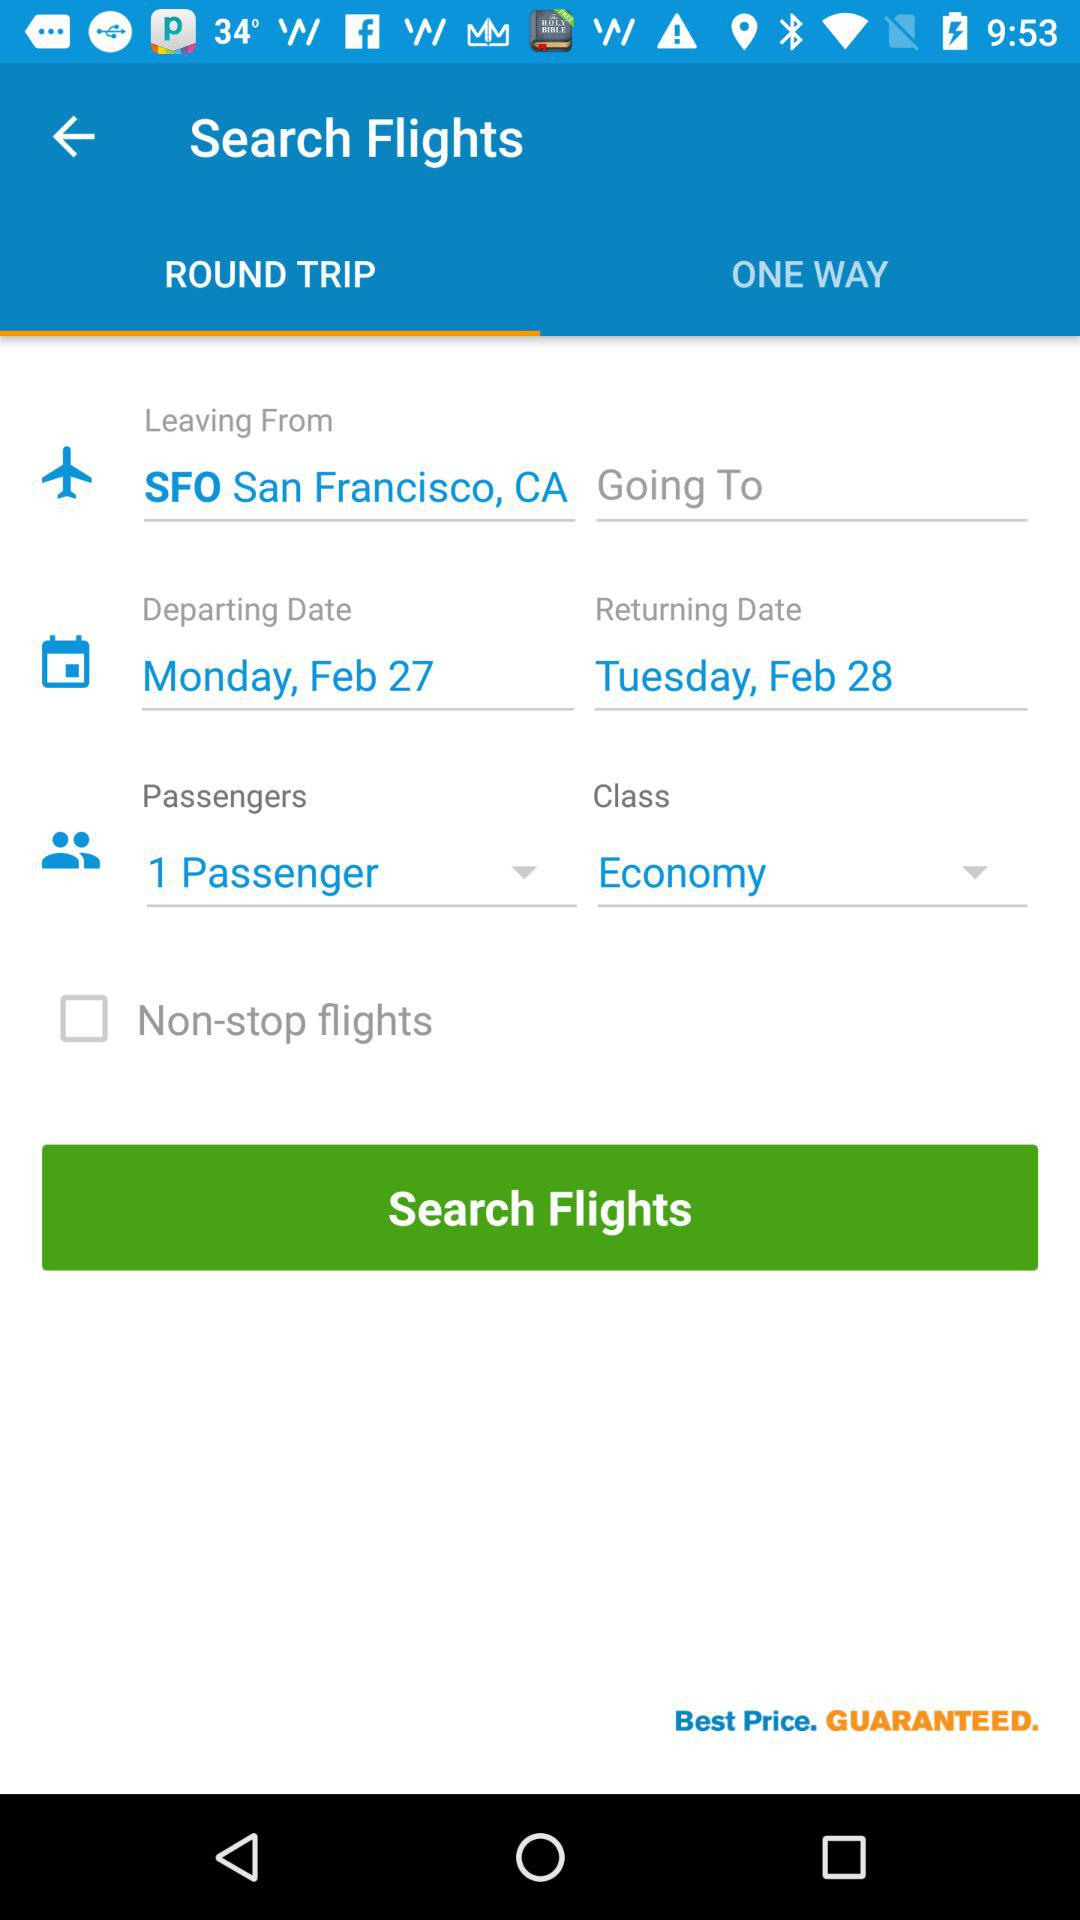How many passengers are selected?
Answer the question using a single word or phrase. 1 